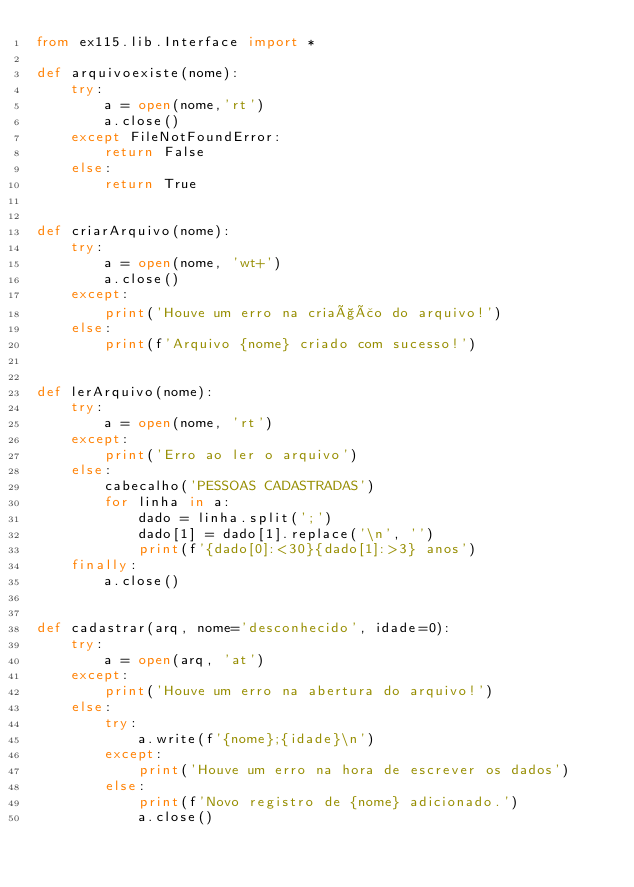Convert code to text. <code><loc_0><loc_0><loc_500><loc_500><_Python_>from ex115.lib.Interface import *

def arquivoexiste(nome):
    try:
        a = open(nome,'rt')
        a.close()
    except FileNotFoundError:
        return False
    else:
        return True


def criarArquivo(nome):
    try:
        a = open(nome, 'wt+')
        a.close()
    except:
        print('Houve um erro na criação do arquivo!')
    else:
        print(f'Arquivo {nome} criado com sucesso!')


def lerArquivo(nome):
    try:
        a = open(nome, 'rt')
    except:
        print('Erro ao ler o arquivo')
    else:
        cabecalho('PESSOAS CADASTRADAS')
        for linha in a:
            dado = linha.split(';')
            dado[1] = dado[1].replace('\n', '')
            print(f'{dado[0]:<30}{dado[1]:>3} anos')
    finally:
        a.close()


def cadastrar(arq, nome='desconhecido', idade=0):
    try:
        a = open(arq, 'at')
    except:
        print('Houve um erro na abertura do arquivo!')
    else:
        try:
            a.write(f'{nome};{idade}\n')
        except:
            print('Houve um erro na hora de escrever os dados')
        else:
            print(f'Novo registro de {nome} adicionado.')
            a.close()

</code> 